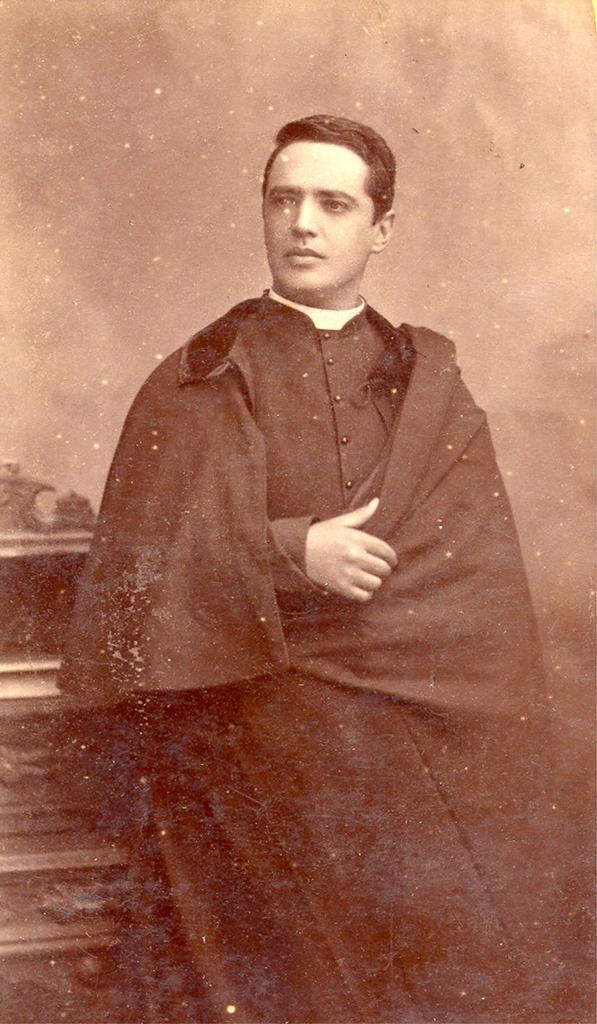Please provide a concise description of this image. In the center of the image there is a person standing. 